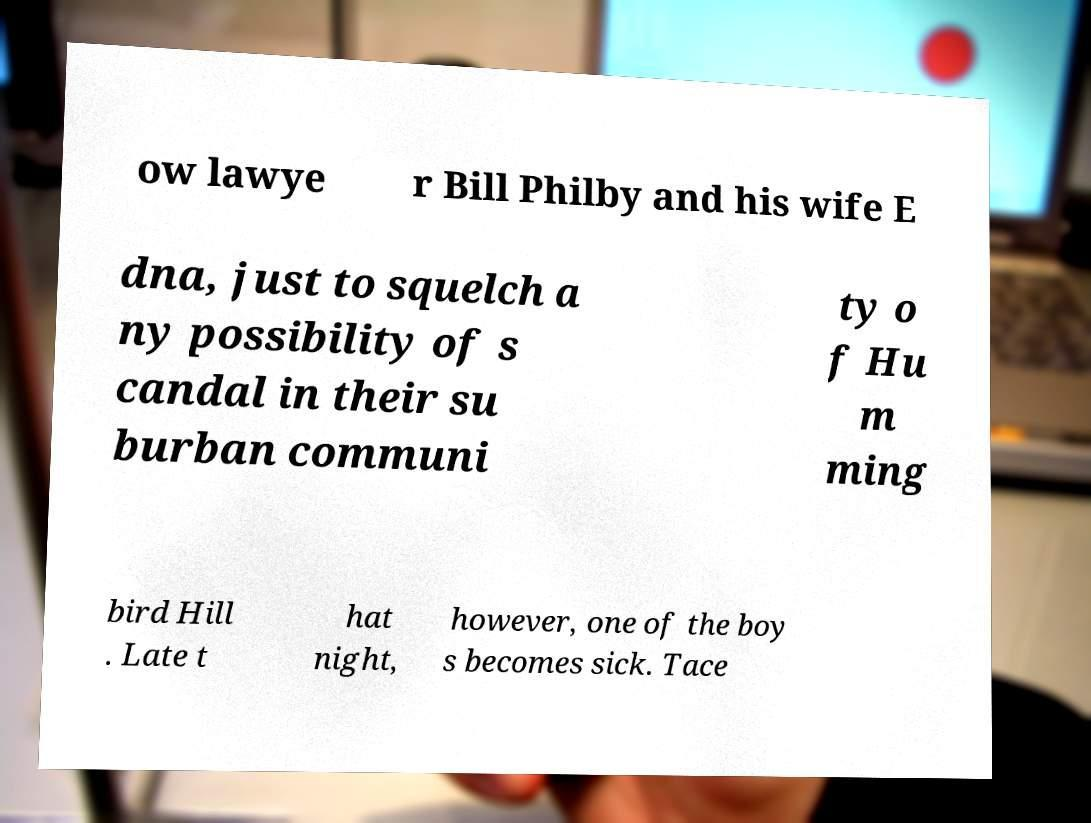Please identify and transcribe the text found in this image. ow lawye r Bill Philby and his wife E dna, just to squelch a ny possibility of s candal in their su burban communi ty o f Hu m ming bird Hill . Late t hat night, however, one of the boy s becomes sick. Tace 